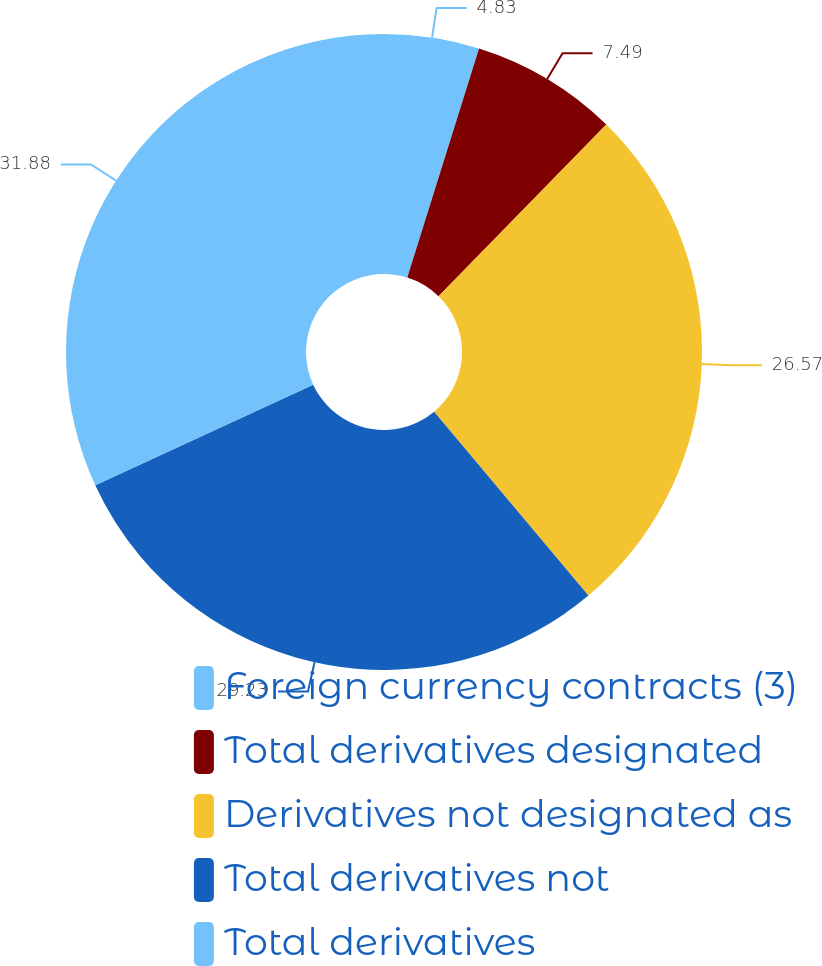Convert chart to OTSL. <chart><loc_0><loc_0><loc_500><loc_500><pie_chart><fcel>Foreign currency contracts (3)<fcel>Total derivatives designated<fcel>Derivatives not designated as<fcel>Total derivatives not<fcel>Total derivatives<nl><fcel>4.83%<fcel>7.49%<fcel>26.57%<fcel>29.23%<fcel>31.88%<nl></chart> 